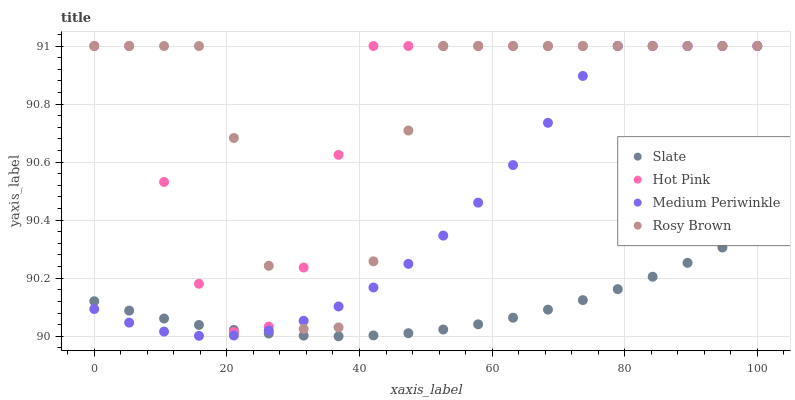Does Slate have the minimum area under the curve?
Answer yes or no. Yes. Does Rosy Brown have the maximum area under the curve?
Answer yes or no. Yes. Does Hot Pink have the minimum area under the curve?
Answer yes or no. No. Does Hot Pink have the maximum area under the curve?
Answer yes or no. No. Is Slate the smoothest?
Answer yes or no. Yes. Is Rosy Brown the roughest?
Answer yes or no. Yes. Is Hot Pink the smoothest?
Answer yes or no. No. Is Hot Pink the roughest?
Answer yes or no. No. Does Slate have the lowest value?
Answer yes or no. Yes. Does Hot Pink have the lowest value?
Answer yes or no. No. Does Rosy Brown have the highest value?
Answer yes or no. Yes. Is Slate less than Rosy Brown?
Answer yes or no. Yes. Is Rosy Brown greater than Slate?
Answer yes or no. Yes. Does Hot Pink intersect Slate?
Answer yes or no. Yes. Is Hot Pink less than Slate?
Answer yes or no. No. Is Hot Pink greater than Slate?
Answer yes or no. No. Does Slate intersect Rosy Brown?
Answer yes or no. No. 